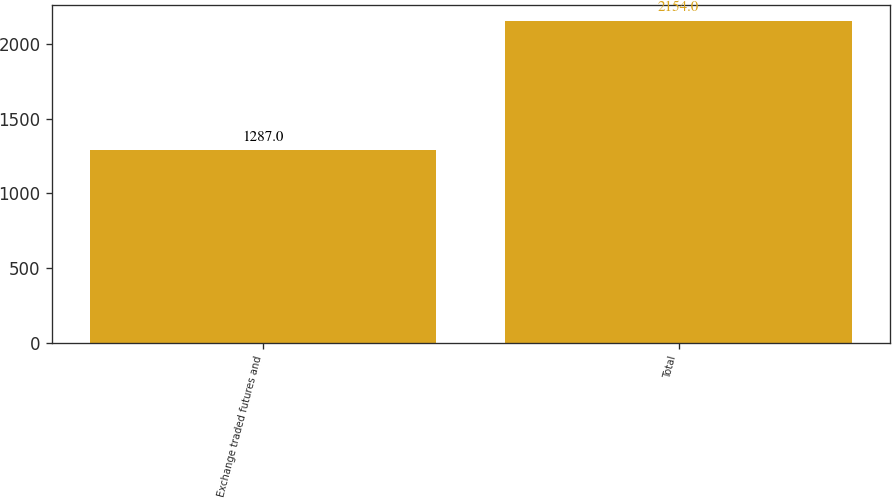<chart> <loc_0><loc_0><loc_500><loc_500><bar_chart><fcel>Exchange traded futures and<fcel>Total<nl><fcel>1287<fcel>2154<nl></chart> 